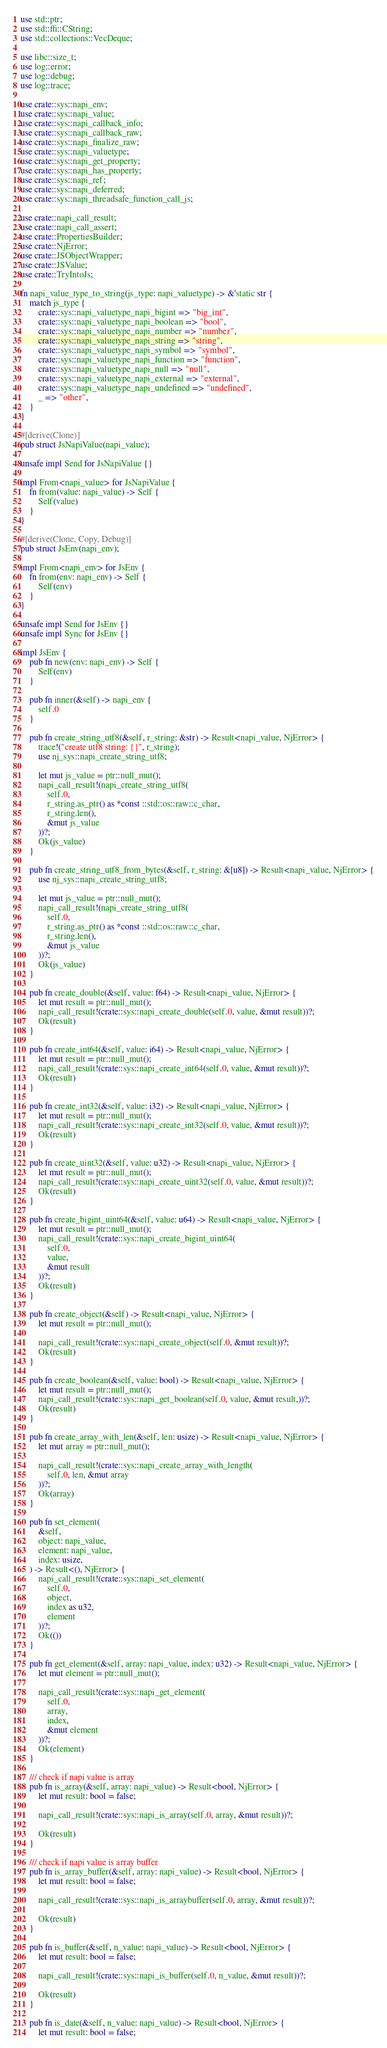Convert code to text. <code><loc_0><loc_0><loc_500><loc_500><_Rust_>use std::ptr;
use std::ffi::CString;
use std::collections::VecDeque;

use libc::size_t;
use log::error;
use log::debug;
use log::trace;

use crate::sys::napi_env;
use crate::sys::napi_value;
use crate::sys::napi_callback_info;
use crate::sys::napi_callback_raw;
use crate::sys::napi_finalize_raw;
use crate::sys::napi_valuetype;
use crate::sys::napi_get_property;
use crate::sys::napi_has_property;
use crate::sys::napi_ref;
use crate::sys::napi_deferred;
use crate::sys::napi_threadsafe_function_call_js;

use crate::napi_call_result;
use crate::napi_call_assert;
use crate::PropertiesBuilder;
use crate::NjError;
use crate::JSObjectWrapper;
use crate::JSValue;
use crate::TryIntoJs;

fn napi_value_type_to_string(js_type: napi_valuetype) -> &'static str {
    match js_type {
        crate::sys::napi_valuetype_napi_bigint => "big_int",
        crate::sys::napi_valuetype_napi_boolean => "bool",
        crate::sys::napi_valuetype_napi_number => "number",
        crate::sys::napi_valuetype_napi_string => "string",
        crate::sys::napi_valuetype_napi_symbol => "symbol",
        crate::sys::napi_valuetype_napi_function => "function",
        crate::sys::napi_valuetype_napi_null => "null",
        crate::sys::napi_valuetype_napi_external => "external",
        crate::sys::napi_valuetype_napi_undefined => "undefined",
        _ => "other",
    }
}

#[derive(Clone)]
pub struct JsNapiValue(napi_value);

unsafe impl Send for JsNapiValue {}

impl From<napi_value> for JsNapiValue {
    fn from(value: napi_value) -> Self {
        Self(value)
    }
}

#[derive(Clone, Copy, Debug)]
pub struct JsEnv(napi_env);

impl From<napi_env> for JsEnv {
    fn from(env: napi_env) -> Self {
        Self(env)
    }
}

unsafe impl Send for JsEnv {}
unsafe impl Sync for JsEnv {}

impl JsEnv {
    pub fn new(env: napi_env) -> Self {
        Self(env)
    }

    pub fn inner(&self) -> napi_env {
        self.0
    }

    pub fn create_string_utf8(&self, r_string: &str) -> Result<napi_value, NjError> {
        trace!("create utf8 string: {}", r_string);
        use nj_sys::napi_create_string_utf8;

        let mut js_value = ptr::null_mut();
        napi_call_result!(napi_create_string_utf8(
            self.0,
            r_string.as_ptr() as *const ::std::os::raw::c_char,
            r_string.len(),
            &mut js_value
        ))?;
        Ok(js_value)
    }

    pub fn create_string_utf8_from_bytes(&self, r_string: &[u8]) -> Result<napi_value, NjError> {
        use nj_sys::napi_create_string_utf8;

        let mut js_value = ptr::null_mut();
        napi_call_result!(napi_create_string_utf8(
            self.0,
            r_string.as_ptr() as *const ::std::os::raw::c_char,
            r_string.len(),
            &mut js_value
        ))?;
        Ok(js_value)
    }

    pub fn create_double(&self, value: f64) -> Result<napi_value, NjError> {
        let mut result = ptr::null_mut();
        napi_call_result!(crate::sys::napi_create_double(self.0, value, &mut result))?;
        Ok(result)
    }

    pub fn create_int64(&self, value: i64) -> Result<napi_value, NjError> {
        let mut result = ptr::null_mut();
        napi_call_result!(crate::sys::napi_create_int64(self.0, value, &mut result))?;
        Ok(result)
    }

    pub fn create_int32(&self, value: i32) -> Result<napi_value, NjError> {
        let mut result = ptr::null_mut();
        napi_call_result!(crate::sys::napi_create_int32(self.0, value, &mut result))?;
        Ok(result)
    }

    pub fn create_uint32(&self, value: u32) -> Result<napi_value, NjError> {
        let mut result = ptr::null_mut();
        napi_call_result!(crate::sys::napi_create_uint32(self.0, value, &mut result))?;
        Ok(result)
    }

    pub fn create_bigint_uint64(&self, value: u64) -> Result<napi_value, NjError> {
        let mut result = ptr::null_mut();
        napi_call_result!(crate::sys::napi_create_bigint_uint64(
            self.0,
            value,
            &mut result
        ))?;
        Ok(result)
    }

    pub fn create_object(&self) -> Result<napi_value, NjError> {
        let mut result = ptr::null_mut();

        napi_call_result!(crate::sys::napi_create_object(self.0, &mut result))?;
        Ok(result)
    }

    pub fn create_boolean(&self, value: bool) -> Result<napi_value, NjError> {
        let mut result = ptr::null_mut();
        napi_call_result!(crate::sys::napi_get_boolean(self.0, value, &mut result,))?;
        Ok(result)
    }

    pub fn create_array_with_len(&self, len: usize) -> Result<napi_value, NjError> {
        let mut array = ptr::null_mut();

        napi_call_result!(crate::sys::napi_create_array_with_length(
            self.0, len, &mut array
        ))?;
        Ok(array)
    }

    pub fn set_element(
        &self,
        object: napi_value,
        element: napi_value,
        index: usize,
    ) -> Result<(), NjError> {
        napi_call_result!(crate::sys::napi_set_element(
            self.0,
            object,
            index as u32,
            element
        ))?;
        Ok(())
    }

    pub fn get_element(&self, array: napi_value, index: u32) -> Result<napi_value, NjError> {
        let mut element = ptr::null_mut();

        napi_call_result!(crate::sys::napi_get_element(
            self.0,
            array,
            index,
            &mut element
        ))?;
        Ok(element)
    }

    /// check if napi value is array
    pub fn is_array(&self, array: napi_value) -> Result<bool, NjError> {
        let mut result: bool = false;

        napi_call_result!(crate::sys::napi_is_array(self.0, array, &mut result))?;

        Ok(result)
    }

    /// check if napi value is array buffer
    pub fn is_array_buffer(&self, array: napi_value) -> Result<bool, NjError> {
        let mut result: bool = false;

        napi_call_result!(crate::sys::napi_is_arraybuffer(self.0, array, &mut result))?;

        Ok(result)
    }

    pub fn is_buffer(&self, n_value: napi_value) -> Result<bool, NjError> {
        let mut result: bool = false;

        napi_call_result!(crate::sys::napi_is_buffer(self.0, n_value, &mut result))?;

        Ok(result)
    }

    pub fn is_date(&self, n_value: napi_value) -> Result<bool, NjError> {
        let mut result: bool = false;
</code> 